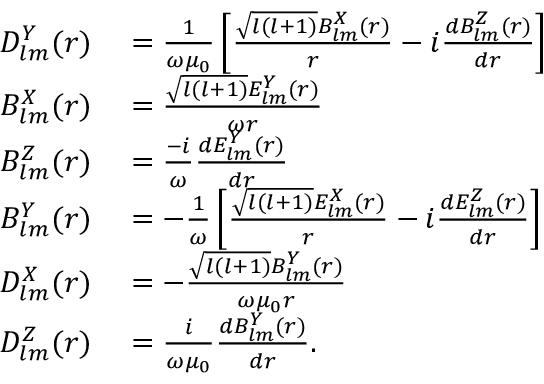Convert formula to latex. <formula><loc_0><loc_0><loc_500><loc_500>\begin{array} { r l } { D _ { l m } ^ { Y } ( r ) } & = \frac { 1 } { \omega \mu _ { 0 } } \left [ \frac { \sqrt { l ( l + 1 ) } B _ { l m } ^ { X } ( r ) } { r } - i \frac { d B _ { l m } ^ { Z } ( r ) } { d r } \right ] } \\ { B _ { l m } ^ { X } ( r ) } & = \frac { \sqrt { l ( l + 1 ) } E _ { l m } ^ { Y } ( r ) } { \omega r } } \\ { B _ { l m } ^ { Z } ( r ) } & = \frac { - i } { \omega } \frac { d E _ { l m } ^ { Y } ( r ) } { d r } } \\ { B _ { l m } ^ { Y } ( r ) } & = - \frac { 1 } { \omega } \left [ \frac { \sqrt { l ( l + 1 ) } E _ { l m } ^ { X } ( r ) } { r } - i \frac { d E _ { l m } ^ { Z } ( r ) } { d r } \right ] } \\ { D _ { l m } ^ { X } ( r ) } & = - \frac { \sqrt { l ( l + 1 ) } B _ { l m } ^ { Y } ( r ) } { \omega \mu _ { 0 } r } } \\ { D _ { l m } ^ { Z } ( r ) } & = \frac { i } { \omega \mu _ { 0 } } \frac { d B _ { l m } ^ { Y } ( r ) } { d r } . } \end{array}</formula> 